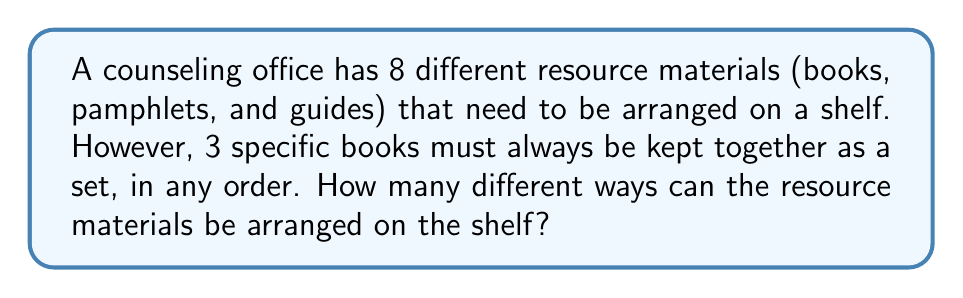Show me your answer to this math problem. Let's approach this problem step by step:

1) First, we need to consider the 3 books that must be kept together as a single unit. This means we effectively have 6 items to arrange:
   - The set of 3 books (treated as one item)
   - The other 5 individual resource materials

2) We can calculate the number of ways to arrange these 6 items using the permutation formula:
   $$ P(6,6) = 6! = 6 \times 5 \times 4 \times 3 \times 2 \times 1 = 720 $$

3) However, we're not done yet. For each of these 720 arrangements, the 3 books within the set can also be arranged in different ways. The number of ways to arrange 3 books is:
   $$ P(3,3) = 3! = 3 \times 2 \times 1 = 6 $$

4) According to the multiplication principle, to get the total number of possible arrangements, we multiply these results:
   $$ 720 \times 6 = 4320 $$

Therefore, there are 4320 different ways to arrange the resource materials on the shelf.
Answer: 4320 